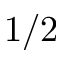Convert formula to latex. <formula><loc_0><loc_0><loc_500><loc_500>1 / 2</formula> 